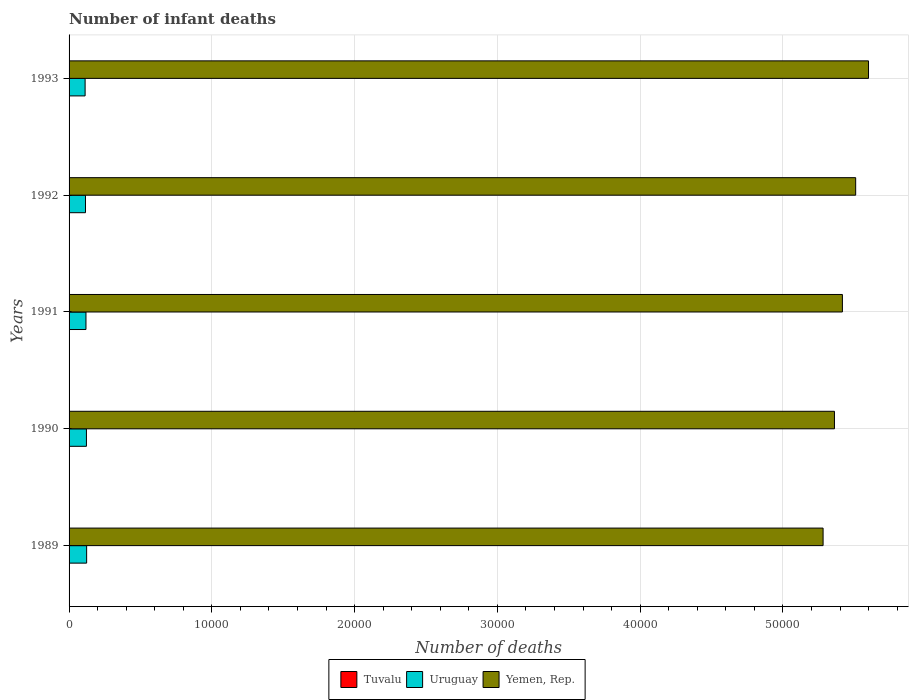How many different coloured bars are there?
Provide a succinct answer. 3. What is the number of infant deaths in Yemen, Rep. in 1993?
Offer a terse response. 5.60e+04. Across all years, what is the maximum number of infant deaths in Yemen, Rep.?
Provide a succinct answer. 5.60e+04. Across all years, what is the minimum number of infant deaths in Uruguay?
Your answer should be compact. 1123. In which year was the number of infant deaths in Tuvalu maximum?
Offer a very short reply. 1989. In which year was the number of infant deaths in Yemen, Rep. minimum?
Provide a short and direct response. 1989. What is the total number of infant deaths in Uruguay in the graph?
Ensure brevity in your answer.  5904. What is the difference between the number of infant deaths in Uruguay in 1990 and that in 1991?
Your answer should be very brief. 32. What is the difference between the number of infant deaths in Uruguay in 1993 and the number of infant deaths in Yemen, Rep. in 1992?
Your answer should be compact. -5.40e+04. What is the average number of infant deaths in Yemen, Rep. per year?
Offer a terse response. 5.43e+04. In the year 1989, what is the difference between the number of infant deaths in Tuvalu and number of infant deaths in Yemen, Rep.?
Ensure brevity in your answer.  -5.28e+04. In how many years, is the number of infant deaths in Uruguay greater than 24000 ?
Your answer should be very brief. 0. What is the ratio of the number of infant deaths in Tuvalu in 1991 to that in 1992?
Make the answer very short. 1.1. Is the number of infant deaths in Uruguay in 1992 less than that in 1993?
Offer a terse response. No. What is the difference between the highest and the second highest number of infant deaths in Yemen, Rep.?
Provide a succinct answer. 900. In how many years, is the number of infant deaths in Uruguay greater than the average number of infant deaths in Uruguay taken over all years?
Your answer should be compact. 3. What does the 3rd bar from the top in 1993 represents?
Your answer should be very brief. Tuvalu. What does the 2nd bar from the bottom in 1990 represents?
Your answer should be very brief. Uruguay. Is it the case that in every year, the sum of the number of infant deaths in Uruguay and number of infant deaths in Tuvalu is greater than the number of infant deaths in Yemen, Rep.?
Ensure brevity in your answer.  No. How many years are there in the graph?
Your response must be concise. 5. Where does the legend appear in the graph?
Ensure brevity in your answer.  Bottom center. How many legend labels are there?
Your answer should be compact. 3. What is the title of the graph?
Ensure brevity in your answer.  Number of infant deaths. Does "New Caledonia" appear as one of the legend labels in the graph?
Give a very brief answer. No. What is the label or title of the X-axis?
Make the answer very short. Number of deaths. What is the label or title of the Y-axis?
Your answer should be very brief. Years. What is the Number of deaths in Tuvalu in 1989?
Provide a succinct answer. 12. What is the Number of deaths in Uruguay in 1989?
Your answer should be compact. 1231. What is the Number of deaths of Yemen, Rep. in 1989?
Provide a succinct answer. 5.28e+04. What is the Number of deaths in Uruguay in 1990?
Provide a short and direct response. 1216. What is the Number of deaths of Yemen, Rep. in 1990?
Ensure brevity in your answer.  5.36e+04. What is the Number of deaths in Tuvalu in 1991?
Your response must be concise. 11. What is the Number of deaths of Uruguay in 1991?
Your answer should be compact. 1184. What is the Number of deaths of Yemen, Rep. in 1991?
Your answer should be compact. 5.42e+04. What is the Number of deaths in Tuvalu in 1992?
Ensure brevity in your answer.  10. What is the Number of deaths in Uruguay in 1992?
Provide a succinct answer. 1150. What is the Number of deaths of Yemen, Rep. in 1992?
Offer a very short reply. 5.51e+04. What is the Number of deaths in Tuvalu in 1993?
Offer a very short reply. 10. What is the Number of deaths of Uruguay in 1993?
Offer a terse response. 1123. What is the Number of deaths in Yemen, Rep. in 1993?
Your response must be concise. 5.60e+04. Across all years, what is the maximum Number of deaths in Uruguay?
Keep it short and to the point. 1231. Across all years, what is the maximum Number of deaths of Yemen, Rep.?
Make the answer very short. 5.60e+04. Across all years, what is the minimum Number of deaths of Uruguay?
Your answer should be very brief. 1123. Across all years, what is the minimum Number of deaths in Yemen, Rep.?
Your answer should be compact. 5.28e+04. What is the total Number of deaths of Tuvalu in the graph?
Make the answer very short. 54. What is the total Number of deaths in Uruguay in the graph?
Give a very brief answer. 5904. What is the total Number of deaths in Yemen, Rep. in the graph?
Provide a short and direct response. 2.72e+05. What is the difference between the Number of deaths in Tuvalu in 1989 and that in 1990?
Ensure brevity in your answer.  1. What is the difference between the Number of deaths of Uruguay in 1989 and that in 1990?
Your response must be concise. 15. What is the difference between the Number of deaths in Yemen, Rep. in 1989 and that in 1990?
Your response must be concise. -796. What is the difference between the Number of deaths of Tuvalu in 1989 and that in 1991?
Keep it short and to the point. 1. What is the difference between the Number of deaths of Uruguay in 1989 and that in 1991?
Your answer should be very brief. 47. What is the difference between the Number of deaths in Yemen, Rep. in 1989 and that in 1991?
Offer a very short reply. -1353. What is the difference between the Number of deaths of Tuvalu in 1989 and that in 1992?
Ensure brevity in your answer.  2. What is the difference between the Number of deaths of Yemen, Rep. in 1989 and that in 1992?
Offer a terse response. -2282. What is the difference between the Number of deaths of Tuvalu in 1989 and that in 1993?
Your answer should be compact. 2. What is the difference between the Number of deaths of Uruguay in 1989 and that in 1993?
Your answer should be compact. 108. What is the difference between the Number of deaths of Yemen, Rep. in 1989 and that in 1993?
Your answer should be very brief. -3182. What is the difference between the Number of deaths of Tuvalu in 1990 and that in 1991?
Your answer should be compact. 0. What is the difference between the Number of deaths in Uruguay in 1990 and that in 1991?
Your answer should be very brief. 32. What is the difference between the Number of deaths in Yemen, Rep. in 1990 and that in 1991?
Make the answer very short. -557. What is the difference between the Number of deaths of Tuvalu in 1990 and that in 1992?
Ensure brevity in your answer.  1. What is the difference between the Number of deaths in Uruguay in 1990 and that in 1992?
Offer a very short reply. 66. What is the difference between the Number of deaths in Yemen, Rep. in 1990 and that in 1992?
Make the answer very short. -1486. What is the difference between the Number of deaths in Uruguay in 1990 and that in 1993?
Ensure brevity in your answer.  93. What is the difference between the Number of deaths in Yemen, Rep. in 1990 and that in 1993?
Your answer should be compact. -2386. What is the difference between the Number of deaths in Yemen, Rep. in 1991 and that in 1992?
Your answer should be very brief. -929. What is the difference between the Number of deaths of Tuvalu in 1991 and that in 1993?
Your answer should be compact. 1. What is the difference between the Number of deaths of Uruguay in 1991 and that in 1993?
Ensure brevity in your answer.  61. What is the difference between the Number of deaths of Yemen, Rep. in 1991 and that in 1993?
Ensure brevity in your answer.  -1829. What is the difference between the Number of deaths in Tuvalu in 1992 and that in 1993?
Make the answer very short. 0. What is the difference between the Number of deaths in Yemen, Rep. in 1992 and that in 1993?
Provide a succinct answer. -900. What is the difference between the Number of deaths in Tuvalu in 1989 and the Number of deaths in Uruguay in 1990?
Offer a terse response. -1204. What is the difference between the Number of deaths of Tuvalu in 1989 and the Number of deaths of Yemen, Rep. in 1990?
Keep it short and to the point. -5.36e+04. What is the difference between the Number of deaths in Uruguay in 1989 and the Number of deaths in Yemen, Rep. in 1990?
Your answer should be very brief. -5.24e+04. What is the difference between the Number of deaths of Tuvalu in 1989 and the Number of deaths of Uruguay in 1991?
Make the answer very short. -1172. What is the difference between the Number of deaths of Tuvalu in 1989 and the Number of deaths of Yemen, Rep. in 1991?
Provide a short and direct response. -5.42e+04. What is the difference between the Number of deaths in Uruguay in 1989 and the Number of deaths in Yemen, Rep. in 1991?
Offer a very short reply. -5.29e+04. What is the difference between the Number of deaths in Tuvalu in 1989 and the Number of deaths in Uruguay in 1992?
Ensure brevity in your answer.  -1138. What is the difference between the Number of deaths of Tuvalu in 1989 and the Number of deaths of Yemen, Rep. in 1992?
Your answer should be very brief. -5.51e+04. What is the difference between the Number of deaths of Uruguay in 1989 and the Number of deaths of Yemen, Rep. in 1992?
Your answer should be compact. -5.39e+04. What is the difference between the Number of deaths of Tuvalu in 1989 and the Number of deaths of Uruguay in 1993?
Your response must be concise. -1111. What is the difference between the Number of deaths in Tuvalu in 1989 and the Number of deaths in Yemen, Rep. in 1993?
Your answer should be compact. -5.60e+04. What is the difference between the Number of deaths in Uruguay in 1989 and the Number of deaths in Yemen, Rep. in 1993?
Give a very brief answer. -5.48e+04. What is the difference between the Number of deaths of Tuvalu in 1990 and the Number of deaths of Uruguay in 1991?
Offer a terse response. -1173. What is the difference between the Number of deaths of Tuvalu in 1990 and the Number of deaths of Yemen, Rep. in 1991?
Make the answer very short. -5.42e+04. What is the difference between the Number of deaths in Uruguay in 1990 and the Number of deaths in Yemen, Rep. in 1991?
Make the answer very short. -5.30e+04. What is the difference between the Number of deaths in Tuvalu in 1990 and the Number of deaths in Uruguay in 1992?
Your answer should be compact. -1139. What is the difference between the Number of deaths of Tuvalu in 1990 and the Number of deaths of Yemen, Rep. in 1992?
Offer a terse response. -5.51e+04. What is the difference between the Number of deaths in Uruguay in 1990 and the Number of deaths in Yemen, Rep. in 1992?
Your response must be concise. -5.39e+04. What is the difference between the Number of deaths in Tuvalu in 1990 and the Number of deaths in Uruguay in 1993?
Your response must be concise. -1112. What is the difference between the Number of deaths in Tuvalu in 1990 and the Number of deaths in Yemen, Rep. in 1993?
Keep it short and to the point. -5.60e+04. What is the difference between the Number of deaths of Uruguay in 1990 and the Number of deaths of Yemen, Rep. in 1993?
Give a very brief answer. -5.48e+04. What is the difference between the Number of deaths in Tuvalu in 1991 and the Number of deaths in Uruguay in 1992?
Your response must be concise. -1139. What is the difference between the Number of deaths of Tuvalu in 1991 and the Number of deaths of Yemen, Rep. in 1992?
Provide a succinct answer. -5.51e+04. What is the difference between the Number of deaths in Uruguay in 1991 and the Number of deaths in Yemen, Rep. in 1992?
Offer a terse response. -5.39e+04. What is the difference between the Number of deaths in Tuvalu in 1991 and the Number of deaths in Uruguay in 1993?
Keep it short and to the point. -1112. What is the difference between the Number of deaths in Tuvalu in 1991 and the Number of deaths in Yemen, Rep. in 1993?
Provide a short and direct response. -5.60e+04. What is the difference between the Number of deaths in Uruguay in 1991 and the Number of deaths in Yemen, Rep. in 1993?
Ensure brevity in your answer.  -5.48e+04. What is the difference between the Number of deaths in Tuvalu in 1992 and the Number of deaths in Uruguay in 1993?
Provide a short and direct response. -1113. What is the difference between the Number of deaths in Tuvalu in 1992 and the Number of deaths in Yemen, Rep. in 1993?
Keep it short and to the point. -5.60e+04. What is the difference between the Number of deaths in Uruguay in 1992 and the Number of deaths in Yemen, Rep. in 1993?
Provide a succinct answer. -5.48e+04. What is the average Number of deaths in Tuvalu per year?
Your answer should be very brief. 10.8. What is the average Number of deaths in Uruguay per year?
Your answer should be very brief. 1180.8. What is the average Number of deaths in Yemen, Rep. per year?
Make the answer very short. 5.43e+04. In the year 1989, what is the difference between the Number of deaths of Tuvalu and Number of deaths of Uruguay?
Provide a short and direct response. -1219. In the year 1989, what is the difference between the Number of deaths of Tuvalu and Number of deaths of Yemen, Rep.?
Your answer should be very brief. -5.28e+04. In the year 1989, what is the difference between the Number of deaths of Uruguay and Number of deaths of Yemen, Rep.?
Provide a succinct answer. -5.16e+04. In the year 1990, what is the difference between the Number of deaths of Tuvalu and Number of deaths of Uruguay?
Make the answer very short. -1205. In the year 1990, what is the difference between the Number of deaths in Tuvalu and Number of deaths in Yemen, Rep.?
Provide a succinct answer. -5.36e+04. In the year 1990, what is the difference between the Number of deaths of Uruguay and Number of deaths of Yemen, Rep.?
Make the answer very short. -5.24e+04. In the year 1991, what is the difference between the Number of deaths in Tuvalu and Number of deaths in Uruguay?
Make the answer very short. -1173. In the year 1991, what is the difference between the Number of deaths in Tuvalu and Number of deaths in Yemen, Rep.?
Keep it short and to the point. -5.42e+04. In the year 1991, what is the difference between the Number of deaths of Uruguay and Number of deaths of Yemen, Rep.?
Ensure brevity in your answer.  -5.30e+04. In the year 1992, what is the difference between the Number of deaths in Tuvalu and Number of deaths in Uruguay?
Offer a very short reply. -1140. In the year 1992, what is the difference between the Number of deaths in Tuvalu and Number of deaths in Yemen, Rep.?
Make the answer very short. -5.51e+04. In the year 1992, what is the difference between the Number of deaths of Uruguay and Number of deaths of Yemen, Rep.?
Ensure brevity in your answer.  -5.39e+04. In the year 1993, what is the difference between the Number of deaths of Tuvalu and Number of deaths of Uruguay?
Offer a very short reply. -1113. In the year 1993, what is the difference between the Number of deaths of Tuvalu and Number of deaths of Yemen, Rep.?
Keep it short and to the point. -5.60e+04. In the year 1993, what is the difference between the Number of deaths of Uruguay and Number of deaths of Yemen, Rep.?
Your response must be concise. -5.49e+04. What is the ratio of the Number of deaths of Uruguay in 1989 to that in 1990?
Keep it short and to the point. 1.01. What is the ratio of the Number of deaths in Yemen, Rep. in 1989 to that in 1990?
Offer a terse response. 0.99. What is the ratio of the Number of deaths in Uruguay in 1989 to that in 1991?
Provide a succinct answer. 1.04. What is the ratio of the Number of deaths in Yemen, Rep. in 1989 to that in 1991?
Your answer should be compact. 0.97. What is the ratio of the Number of deaths in Uruguay in 1989 to that in 1992?
Provide a short and direct response. 1.07. What is the ratio of the Number of deaths in Yemen, Rep. in 1989 to that in 1992?
Ensure brevity in your answer.  0.96. What is the ratio of the Number of deaths in Tuvalu in 1989 to that in 1993?
Offer a terse response. 1.2. What is the ratio of the Number of deaths in Uruguay in 1989 to that in 1993?
Your answer should be compact. 1.1. What is the ratio of the Number of deaths of Yemen, Rep. in 1989 to that in 1993?
Ensure brevity in your answer.  0.94. What is the ratio of the Number of deaths of Tuvalu in 1990 to that in 1991?
Your response must be concise. 1. What is the ratio of the Number of deaths in Yemen, Rep. in 1990 to that in 1991?
Give a very brief answer. 0.99. What is the ratio of the Number of deaths of Uruguay in 1990 to that in 1992?
Your response must be concise. 1.06. What is the ratio of the Number of deaths of Yemen, Rep. in 1990 to that in 1992?
Keep it short and to the point. 0.97. What is the ratio of the Number of deaths in Tuvalu in 1990 to that in 1993?
Give a very brief answer. 1.1. What is the ratio of the Number of deaths in Uruguay in 1990 to that in 1993?
Your response must be concise. 1.08. What is the ratio of the Number of deaths in Yemen, Rep. in 1990 to that in 1993?
Ensure brevity in your answer.  0.96. What is the ratio of the Number of deaths in Tuvalu in 1991 to that in 1992?
Provide a short and direct response. 1.1. What is the ratio of the Number of deaths of Uruguay in 1991 to that in 1992?
Your answer should be very brief. 1.03. What is the ratio of the Number of deaths of Yemen, Rep. in 1991 to that in 1992?
Your answer should be compact. 0.98. What is the ratio of the Number of deaths in Uruguay in 1991 to that in 1993?
Offer a very short reply. 1.05. What is the ratio of the Number of deaths in Yemen, Rep. in 1991 to that in 1993?
Give a very brief answer. 0.97. What is the ratio of the Number of deaths of Tuvalu in 1992 to that in 1993?
Give a very brief answer. 1. What is the ratio of the Number of deaths in Uruguay in 1992 to that in 1993?
Offer a very short reply. 1.02. What is the ratio of the Number of deaths of Yemen, Rep. in 1992 to that in 1993?
Give a very brief answer. 0.98. What is the difference between the highest and the second highest Number of deaths in Uruguay?
Keep it short and to the point. 15. What is the difference between the highest and the second highest Number of deaths of Yemen, Rep.?
Your answer should be compact. 900. What is the difference between the highest and the lowest Number of deaths in Tuvalu?
Your answer should be very brief. 2. What is the difference between the highest and the lowest Number of deaths in Uruguay?
Your response must be concise. 108. What is the difference between the highest and the lowest Number of deaths of Yemen, Rep.?
Your answer should be very brief. 3182. 